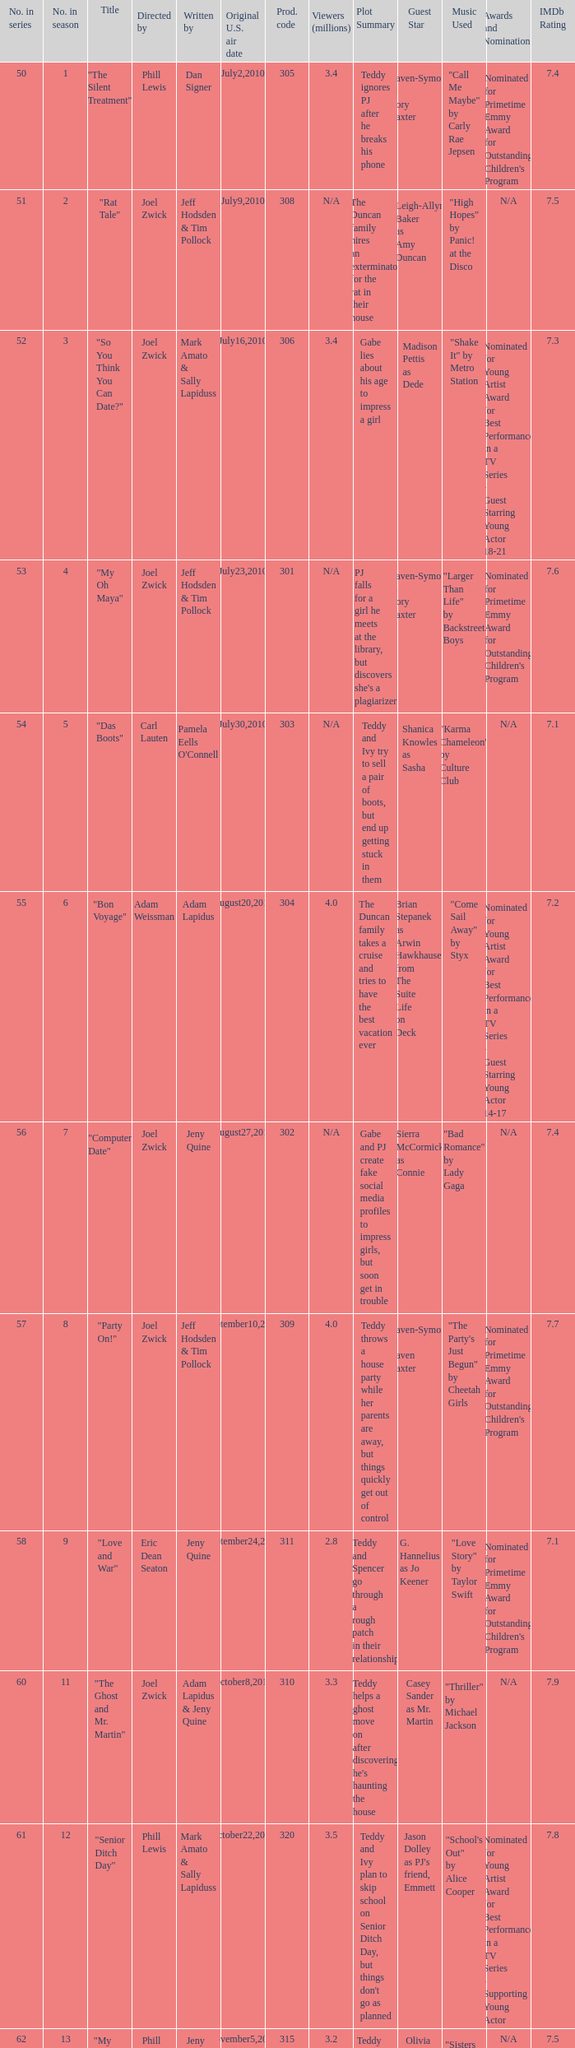Which US air date had 4.4 million viewers? January14,2011. Could you help me parse every detail presented in this table? {'header': ['No. in series', 'No. in season', 'Title', 'Directed by', 'Written by', 'Original U.S. air date', 'Prod. code', 'Viewers (millions)', 'Plot Summary', 'Guest Star', 'Music Used', 'Awards and Nominations', 'IMDb Rating'], 'rows': [['50', '1', '"The Silent Treatment"', 'Phill Lewis', 'Dan Signer', 'July2,2010', '305', '3.4', 'Teddy ignores PJ after he breaks his phone', 'Raven-Symoné as Cory Baxter', '"Call Me Maybe" by Carly Rae Jepsen', "Nominated for Primetime Emmy Award for Outstanding Children's Program", '7.4'], ['51', '2', '"Rat Tale"', 'Joel Zwick', 'Jeff Hodsden & Tim Pollock', 'July9,2010', '308', 'N/A', 'The Duncan family hires an exterminator for the rat in their house', 'Leigh-Allyn Baker as Amy Duncan', '"High Hopes" by Panic! at the Disco', 'N/A', '7.5'], ['52', '3', '"So You Think You Can Date?"', 'Joel Zwick', 'Mark Amato & Sally Lapiduss', 'July16,2010', '306', '3.4', 'Gabe lies about his age to impress a girl', 'Madison Pettis as Dede', '"Shake It" by Metro Station', 'Nominated for Young Artist Award for Best Performance in a TV Series - Guest Starring Young Actor 18-21', '7.3'], ['53', '4', '"My Oh Maya"', 'Joel Zwick', 'Jeff Hodsden & Tim Pollock', 'July23,2010', '301', 'N/A', "PJ falls for a girl he meets at the library, but discovers she's a plagiarizer", 'Raven-Symoné as Cory Baxter', '"Larger Than Life" by Backstreet Boys', "Nominated for Primetime Emmy Award for Outstanding Children's Program", '7.6'], ['54', '5', '"Das Boots"', 'Carl Lauten', "Pamela Eells O'Connell", 'July30,2010', '303', 'N/A', 'Teddy and Ivy try to sell a pair of boots, but end up getting stuck in them', 'Shanica Knowles as Sasha', '"Karma Chameleon" by Culture Club', 'N/A', '7.1'], ['55', '6', '"Bon Voyage"', 'Adam Weissman', 'Adam Lapidus', 'August20,2010', '304', '4.0', 'The Duncan family takes a cruise and tries to have the best vacation ever', 'Brian Stepanek as Arwin Hawkhauser from The Suite Life on Deck', '"Come Sail Away" by Styx', 'Nominated for Young Artist Award for Best Performance in a TV Series - Guest Starring Young Actor 14-17', '7.2'], ['56', '7', '"Computer Date"', 'Joel Zwick', 'Jeny Quine', 'August27,2010', '302', 'N/A', 'Gabe and PJ create fake social media profiles to impress girls, but soon get in trouble', 'Sierra McCormick as Connie', '"Bad Romance" by Lady Gaga', 'N/A', '7.4'], ['57', '8', '"Party On!"', 'Joel Zwick', 'Jeff Hodsden & Tim Pollock', 'September10,2010', '309', '4.0', 'Teddy throws a house party while her parents are away, but things quickly get out of control', 'Raven-Symoné as Raven Baxter', '"The Party\'s Just Begun" by Cheetah Girls', "Nominated for Primetime Emmy Award for Outstanding Children's Program", '7.7'], ['58', '9', '"Love and War"', 'Eric Dean Seaton', 'Jeny Quine', 'September24,2010', '311', '2.8', 'Teddy and Spencer go through a rough patch in their relationship', 'G. Hannelius as Jo Keener', '"Love Story" by Taylor Swift', "Nominated for Primetime Emmy Award for Outstanding Children's Program", '7.1'], ['60', '11', '"The Ghost and Mr. Martin"', 'Joel Zwick', 'Adam Lapidus & Jeny Quine', 'October8,2010', '310', '3.3', "Teddy helps a ghost move on after discovering he's haunting the house", 'Casey Sander as Mr. Martin', '"Thriller" by Michael Jackson', 'N/A', '7.9'], ['61', '12', '"Senior Ditch Day"', 'Phill Lewis', 'Mark Amato & Sally Lapiduss', 'October22,2010', '320', '3.5', "Teddy and Ivy plan to skip school on Senior Ditch Day, but things don't go as planned", "Jason Dolley as PJ's friend, Emmett", '"School\'s Out" by Alice Cooper', 'Nominated for Young Artist Award for Best Performance in a TV Series - Supporting Young Actor', '7.8'], ['62', '13', '"My Sister\'s Keeper"', 'Phill Lewis', 'Jeny Quine', 'November5,2010', '315', '3.2', 'Teddy tries to bond with Charlie, but ends up feeling neglected', 'Olivia Holt as Taylor', '"Sisters and Brothers" by Sidewalk Prophets', 'N/A', '7.5'], ['63', '14', '"Frozen"', 'Phill Lewis', 'Dan Signer', 'November27,2010', '312', 'N/A', 'The Duncan family gets snowed in during a blizzard', 'Leigh-Allyn Baker as Amy Duncan', '"Let It Go" by Idina Menzel', "Nominated for Primetime Emmy Award for Outstanding Children's Program", '7.3'], ['64', '15', '"A London Carol"', 'Shelley Jensen', 'Jeff Hodsden & Tim Pollock', 'December3,2010', '313', '4.1', 'Teddy is visited by three ghosts on Christmas Eve', 'Richard Whiten as Bob', '"Deck the Halls" by Traditional', "Nominated for Writers Guild of America Award for Children's Script - Episodic and Specials", '7.4'], ['65', '16', '"The Play\'s the Thing"', 'Joel Zwick', "Pamela Eells O'Connell", 'January7,2011', '314', '3.6', 'Teddy and Ivy audition for the school play, but end up getting into a fight', 'Aimee Carrero as Wendy', '"One Short Day" from Wicked', 'Nominated for Young Artist Award for Best Performance in a TV Series - Supporting Young Actress', '7.6'], ['66', '17', '"Twister: Part 1"', 'Bob Koherr', 'Adam Lapidus', 'January14,2011', '316', '4.4', 'The Duncan family and their friends are trapped in the house during a tornado warning', 'Raven-Symoné as Raven Baxter', '"Eye of the Storm" by Ryan Stevenson', 'N/A', '7.8'], ['67', '18', '"Twister: Part 2"', 'Bob Koherr', 'Jeff Hodsden & Tim Pollock', 'January15,2011', '317', '5.2', "Teddy and PJ try to get to Charlie's play despite the severe weather", 'Raven-Symoné as Raven Baxter', '"Raindrops Keep Fallin\' on My Head" by B.J. Thomas', 'N/A', '7.7'], ['68', '19', '"Twister: Part 3"', 'Bob Koherr', 'Dan Signer', 'January16,2011', '318', '7.1', "The Duncan family does their best to make it to Charlie's birthday party despite the chaos from the storm", 'Raven-Symoné as Raven Baxter', '"Shelter from the Storm" by Bob Dylan', 'N/A', '7.9'], ['69', '20', '"Snakes on a Boat"', 'Phill Lewis', 'Dan Signer & Adam Lapidus', 'March4,2011', '319', '3.8', 'The Duncans and their friends encounter snakes on a boat ride', 'Emily Osment as Mel', '"Eye of the Tiger" by Survivor', 'N/A', '7.2'], ['70', '21', '"Prom Night"', 'Eric Dean Seaton', 'Jeff Hodsden & Tim Pollock', 'March18,2011', '321', '3.02', 'Teddy gets ready for prom, but finds out her date is cheating on her', 'Adam Hicks as T.J.', '"Boom Boom Pow" by Black Eyed Peas', 'Nominated for Young Artist Award for Best Performance in a TV Series - Supporting Young Actor', '7.5']]} 